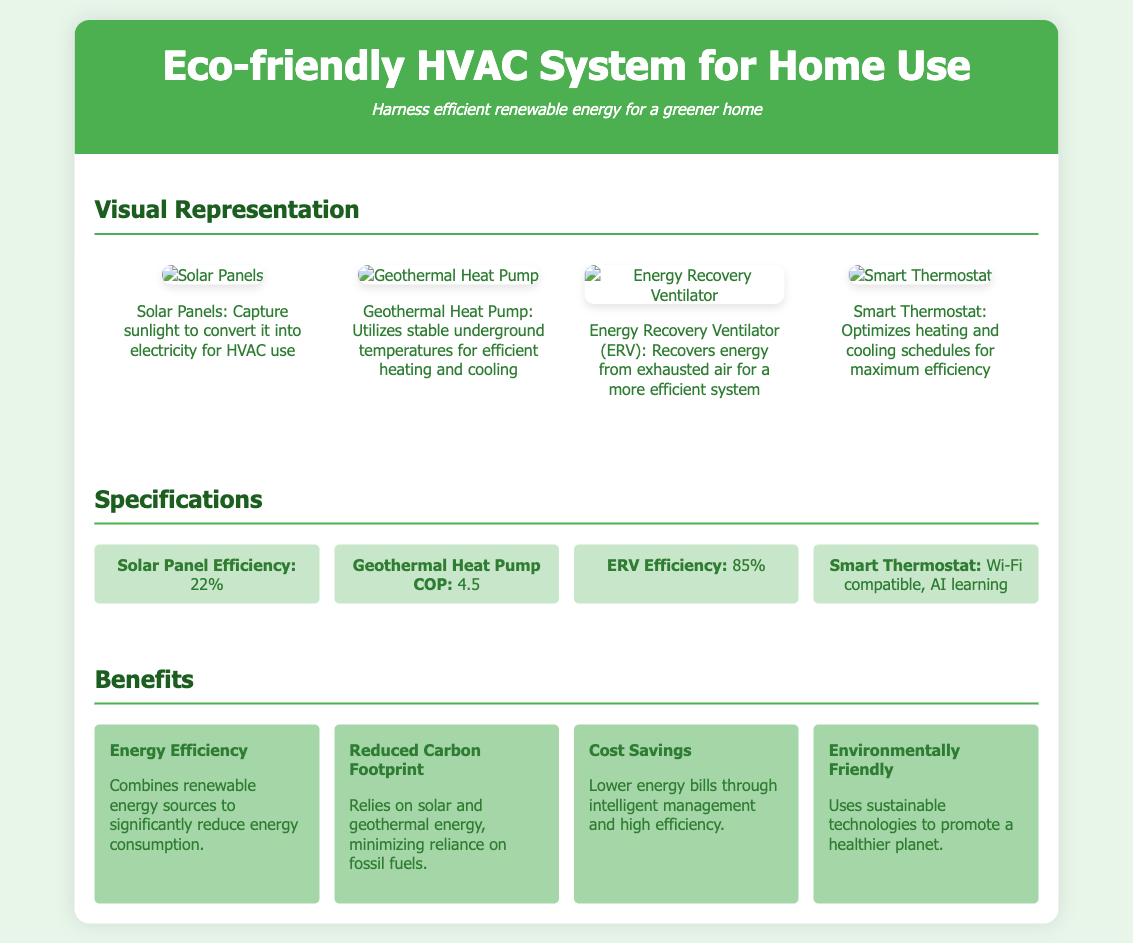What is the efficiency of the solar panels? The solar panel efficiency is explicitly mentioned in the specifications section of the document as 22%.
Answer: 22% What does the geothermal heat pump utilize? The document specifies that the geothermal heat pump utilizes stable underground temperatures for efficient heating and cooling.
Answer: Stable underground temperatures What is the efficiency of the Energy Recovery Ventilator (ERV)? The specifications section states that the ERV efficiency is 85%.
Answer: 85% Which component optimizes heating and cooling schedules? The smart thermostat is identified in the document as the component that optimizes heating and cooling schedules.
Answer: Smart Thermostat How many benefits are listed in the benefits section? The benefits section contains four distinct benefits related to the eco-friendly HVAC system.
Answer: Four What is the Coefficient of Performance (COP) of the geothermal heat pump? According to the specifications, the geothermal heat pump has a COP of 4.5.
Answer: 4.5 What type of technology does the system promote for a healthier planet? The document indicates that the system uses sustainable technologies to promote a healthier planet.
Answer: Sustainable technologies What is the primary reduction focus mentioned in the carbon footprint benefit? The document mentions that the reduced carbon footprint relies on solar and geothermal energy.
Answer: Solar and geothermal energy What does the smart thermostat feature for connectivity? The smart thermostat is Wi-Fi compatible, which is highlighted in the specifications.
Answer: Wi-Fi compatible 